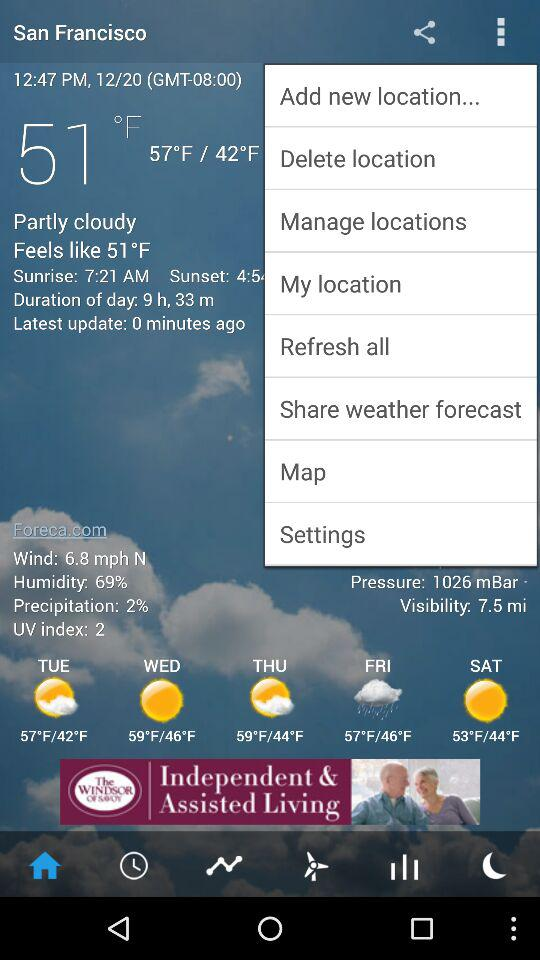What is the humidity of the air?
Answer the question using a single word or phrase. 69% 